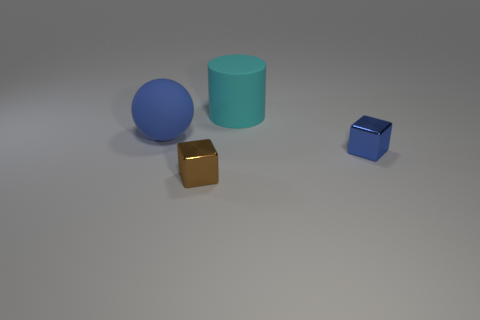Add 3 yellow rubber cylinders. How many objects exist? 7 Subtract all blue cubes. How many cubes are left? 1 Subtract all cylinders. How many objects are left? 3 Subtract all brown cylinders. How many blue blocks are left? 1 Subtract all large cyan cylinders. Subtract all big blue rubber balls. How many objects are left? 2 Add 1 small brown metallic blocks. How many small brown metallic blocks are left? 2 Add 4 cylinders. How many cylinders exist? 5 Subtract 0 cyan spheres. How many objects are left? 4 Subtract all purple balls. Subtract all yellow cubes. How many balls are left? 1 